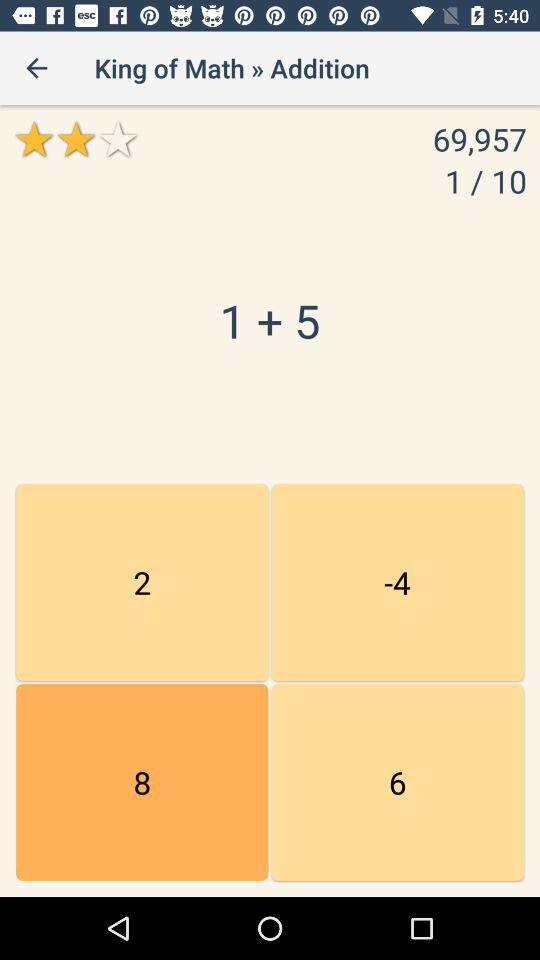What is the name of the application? The name of the application is "King of Math". 